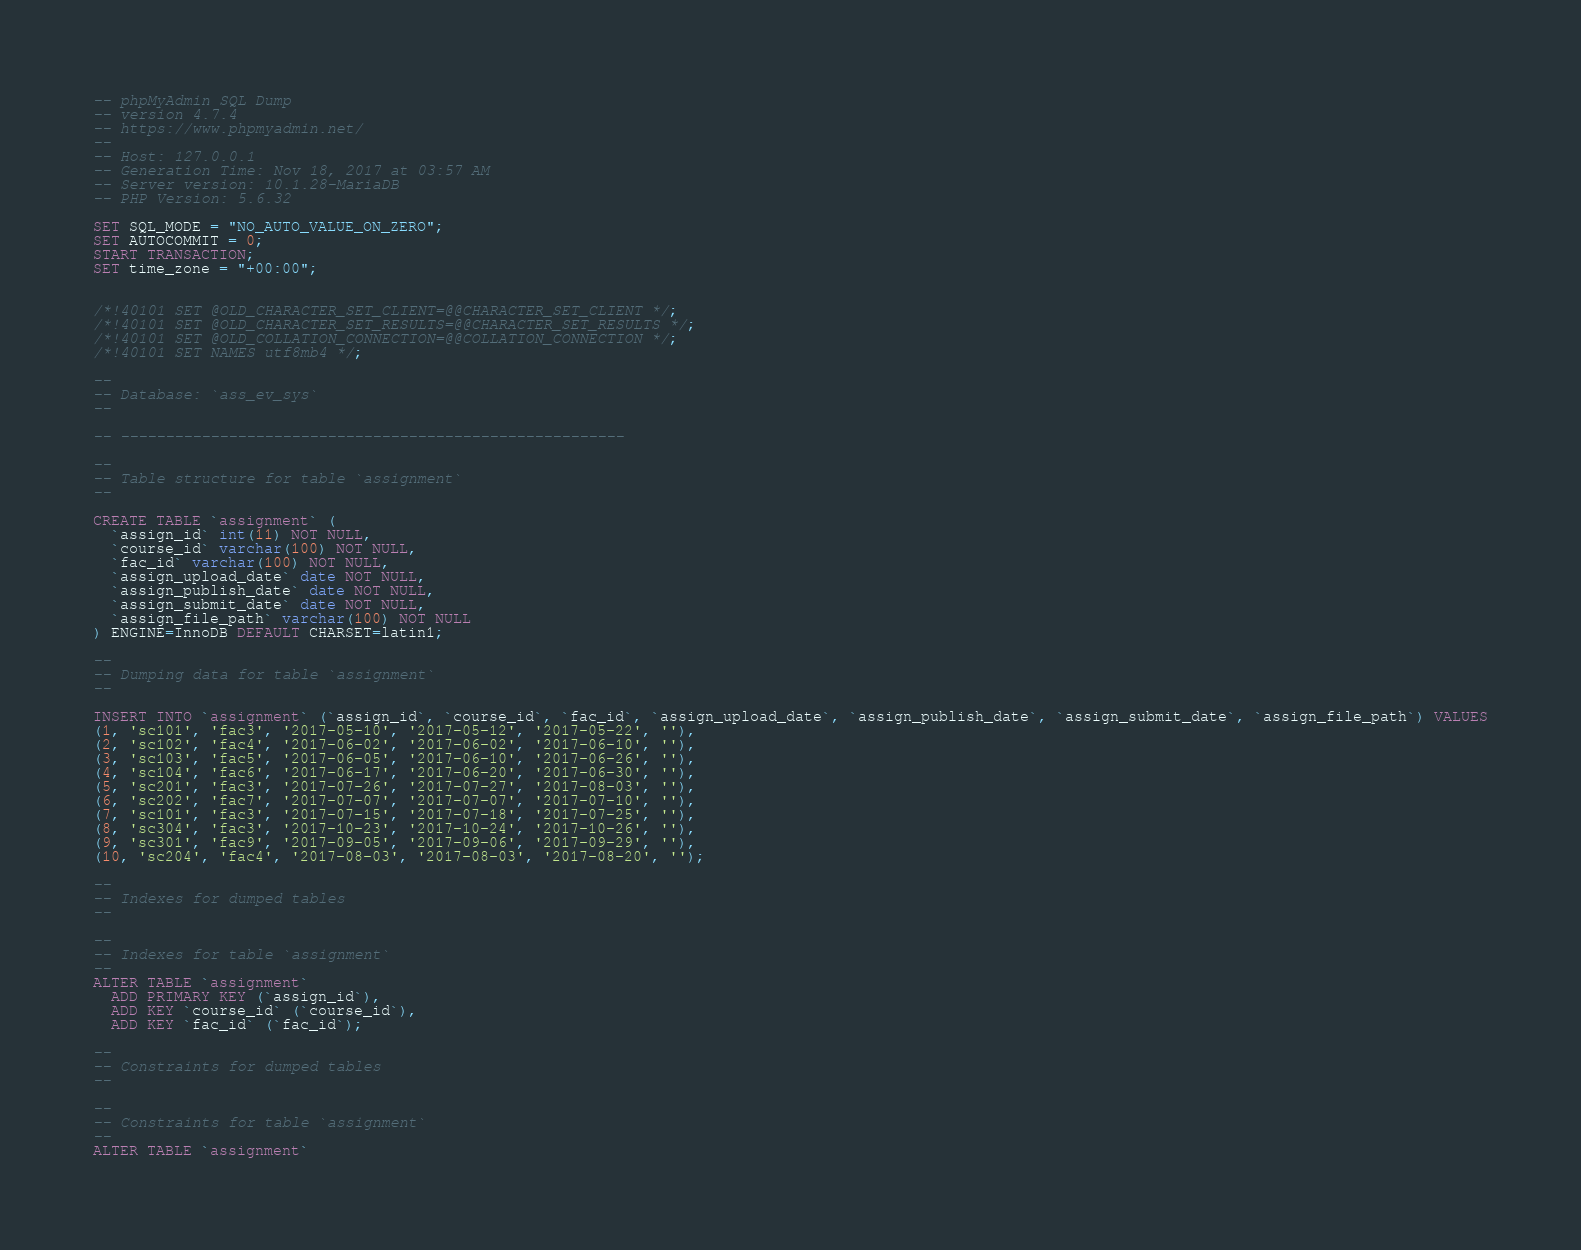<code> <loc_0><loc_0><loc_500><loc_500><_SQL_>-- phpMyAdmin SQL Dump
-- version 4.7.4
-- https://www.phpmyadmin.net/
--
-- Host: 127.0.0.1
-- Generation Time: Nov 18, 2017 at 03:57 AM
-- Server version: 10.1.28-MariaDB
-- PHP Version: 5.6.32

SET SQL_MODE = "NO_AUTO_VALUE_ON_ZERO";
SET AUTOCOMMIT = 0;
START TRANSACTION;
SET time_zone = "+00:00";


/*!40101 SET @OLD_CHARACTER_SET_CLIENT=@@CHARACTER_SET_CLIENT */;
/*!40101 SET @OLD_CHARACTER_SET_RESULTS=@@CHARACTER_SET_RESULTS */;
/*!40101 SET @OLD_COLLATION_CONNECTION=@@COLLATION_CONNECTION */;
/*!40101 SET NAMES utf8mb4 */;

--
-- Database: `ass_ev_sys`
--

-- --------------------------------------------------------

--
-- Table structure for table `assignment`
--

CREATE TABLE `assignment` (
  `assign_id` int(11) NOT NULL,
  `course_id` varchar(100) NOT NULL,
  `fac_id` varchar(100) NOT NULL,
  `assign_upload_date` date NOT NULL,
  `assign_publish_date` date NOT NULL,
  `assign_submit_date` date NOT NULL,
  `assign_file_path` varchar(100) NOT NULL
) ENGINE=InnoDB DEFAULT CHARSET=latin1;

--
-- Dumping data for table `assignment`
--

INSERT INTO `assignment` (`assign_id`, `course_id`, `fac_id`, `assign_upload_date`, `assign_publish_date`, `assign_submit_date`, `assign_file_path`) VALUES
(1, 'sc101', 'fac3', '2017-05-10', '2017-05-12', '2017-05-22', ''),
(2, 'sc102', 'fac4', '2017-06-02', '2017-06-02', '2017-06-10', ''),
(3, 'sc103', 'fac5', '2017-06-05', '2017-06-10', '2017-06-26', ''),
(4, 'sc104', 'fac6', '2017-06-17', '2017-06-20', '2017-06-30', ''),
(5, 'sc201', 'fac3', '2017-07-26', '2017-07-27', '2017-08-03', ''),
(6, 'sc202', 'fac7', '2017-07-07', '2017-07-07', '2017-07-10', ''),
(7, 'sc101', 'fac3', '2017-07-15', '2017-07-18', '2017-07-25', ''),
(8, 'sc304', 'fac3', '2017-10-23', '2017-10-24', '2017-10-26', ''),
(9, 'sc301', 'fac9', '2017-09-05', '2017-09-06', '2017-09-29', ''),
(10, 'sc204', 'fac4', '2017-08-03', '2017-08-03', '2017-08-20', '');

--
-- Indexes for dumped tables
--

--
-- Indexes for table `assignment`
--
ALTER TABLE `assignment`
  ADD PRIMARY KEY (`assign_id`),
  ADD KEY `course_id` (`course_id`),
  ADD KEY `fac_id` (`fac_id`);

--
-- Constraints for dumped tables
--

--
-- Constraints for table `assignment`
--
ALTER TABLE `assignment`</code> 